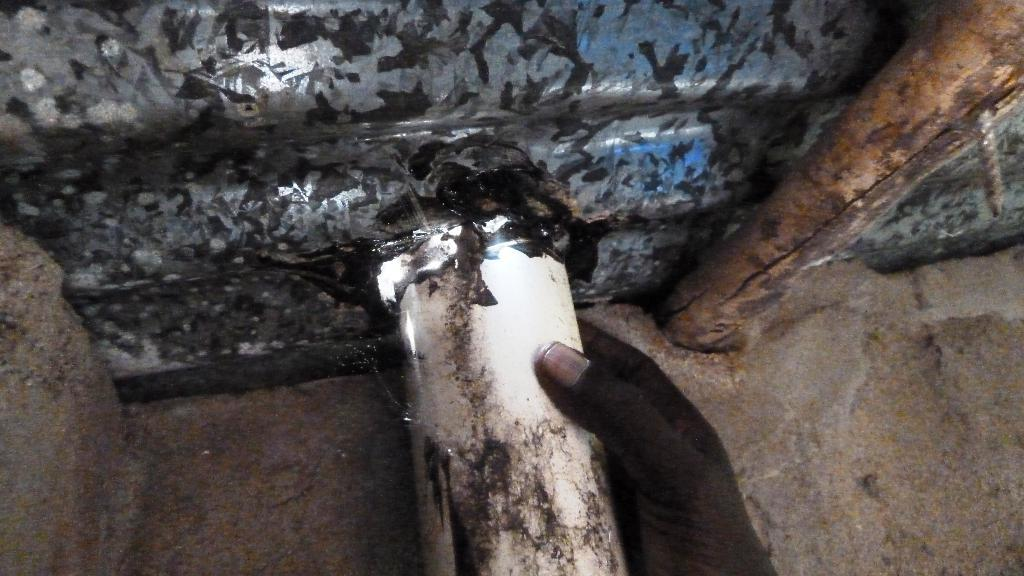What can be seen in the image that belongs to a person? There is a person's hand in the image. What is the hand holding? The hand is holding a pipe. What type of material is visible in the image? There is a metal sheet in the image. What type of texture can be seen on the walls in the image? There is no information about walls or their texture in the provided facts, so we cannot answer this question based on the image. 